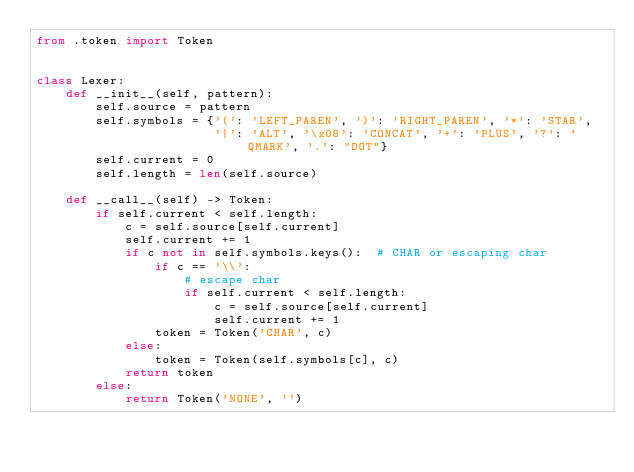<code> <loc_0><loc_0><loc_500><loc_500><_Python_>from .token import Token


class Lexer:
    def __init__(self, pattern):
        self.source = pattern
        self.symbols = {'(': 'LEFT_PAREN', ')': 'RIGHT_PAREN', '*': 'STAR',
                        '|': 'ALT', '\x08': 'CONCAT', '+': 'PLUS', '?': 'QMARK', '.': "DOT"}
        self.current = 0
        self.length = len(self.source)

    def __call__(self) -> Token:
        if self.current < self.length:
            c = self.source[self.current]
            self.current += 1
            if c not in self.symbols.keys():  # CHAR or escaping char
                if c == '\\':
                    # escape char
                    if self.current < self.length:
                        c = self.source[self.current]
                        self.current += 1
                token = Token('CHAR', c)
            else:
                token = Token(self.symbols[c], c)
            return token
        else:
            return Token('NONE', '')
</code> 